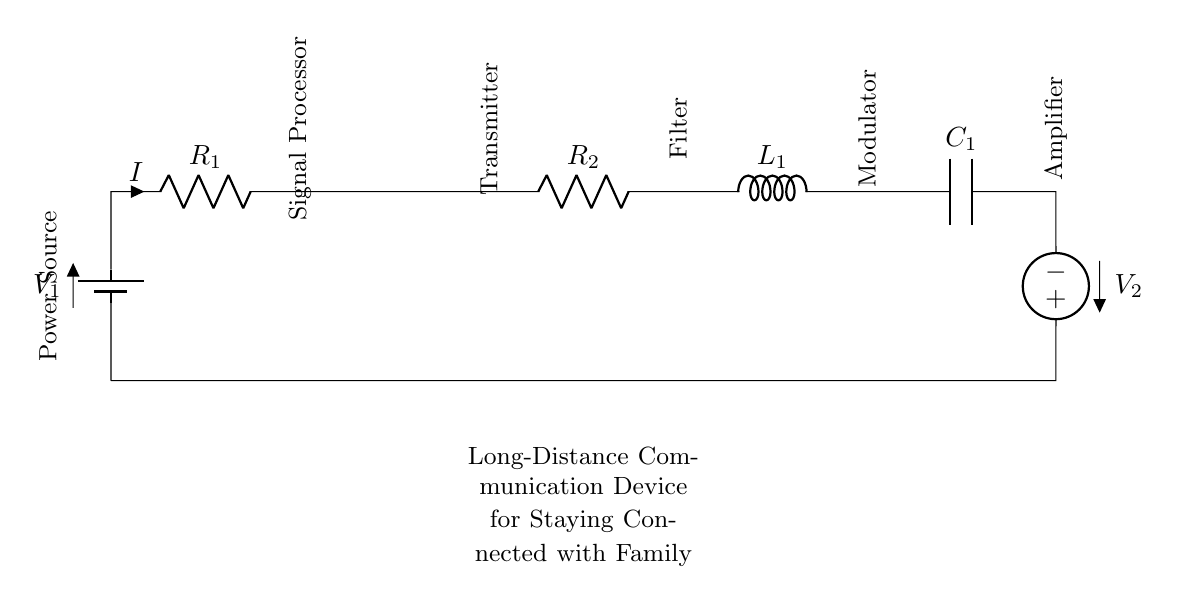What is the total number of components in the circuit? The circuit diagram includes a battery, two resistors, an antenna, an inductor, a capacitor, and an American voltage source. Counting these gives us a total of six components.
Answer: Six What is the purpose of the antenna in this circuit? The antenna is used for transmitting and receiving radio signals, which is essential for long-distance communication. Therefore, its role is to make wireless connections possible with family members.
Answer: Transmit/receive signals How many resistors are present in this circuit? The circuit contains two resistors labeled R1 and R2. By simply counting these components, we reach the conclusion that there are two resistors.
Answer: Two What does the label 'V2' represent in this circuit? The label 'V2' indicates an American voltage source, which means it provides additional voltage to the circuit. Its placement suggests that it plays a critical role in ensuring adequate power supply for the communication device.
Answer: Additional voltage source How does the voltage flow through the circuit? The voltage flows from the first battery, through resistor R1, follows through various components such as the antenna and filter, passes through the inductor and capacitor, and finally returns to the second voltage source, completing the circuit loop.
Answer: From battery to voltage source 